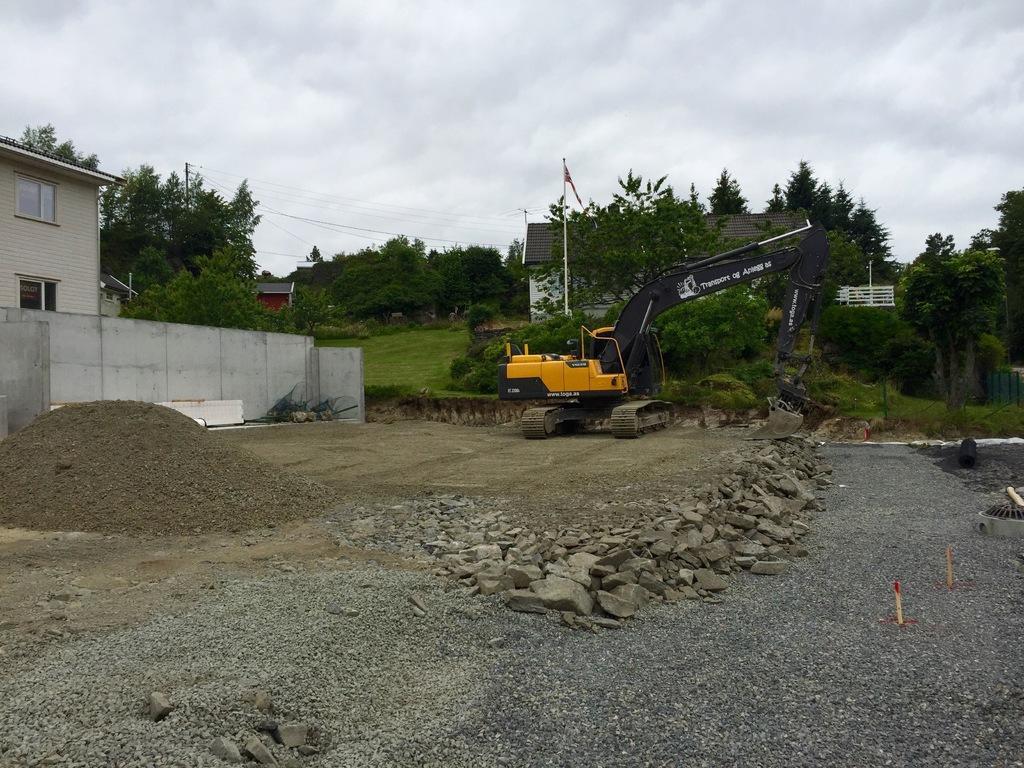Could you give a brief overview of what you see in this image? In this picture I can see the soil and stones in front and in the middle of this picture I can see few buildings, a vehicle and number of trees. In the background I can see the cloudy sky. 